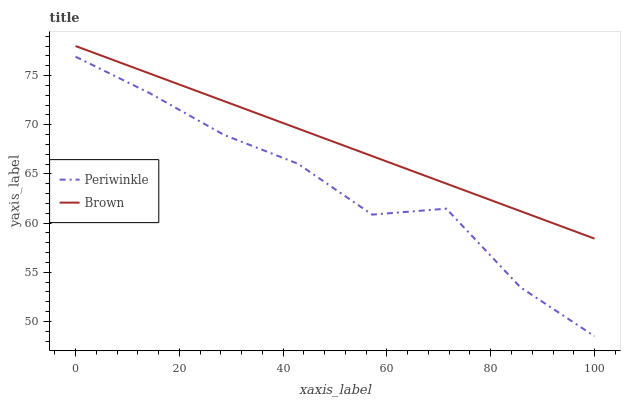Does Periwinkle have the minimum area under the curve?
Answer yes or no. Yes. Does Brown have the maximum area under the curve?
Answer yes or no. Yes. Does Periwinkle have the maximum area under the curve?
Answer yes or no. No. Is Brown the smoothest?
Answer yes or no. Yes. Is Periwinkle the roughest?
Answer yes or no. Yes. Is Periwinkle the smoothest?
Answer yes or no. No. Does Periwinkle have the lowest value?
Answer yes or no. Yes. Does Brown have the highest value?
Answer yes or no. Yes. Does Periwinkle have the highest value?
Answer yes or no. No. Is Periwinkle less than Brown?
Answer yes or no. Yes. Is Brown greater than Periwinkle?
Answer yes or no. Yes. Does Periwinkle intersect Brown?
Answer yes or no. No. 